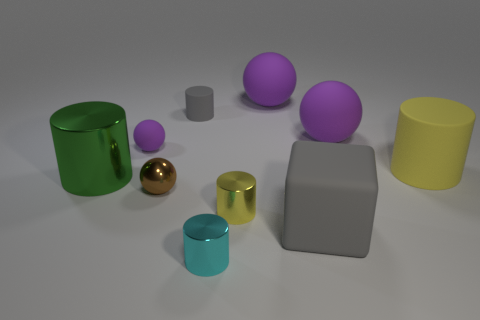How would you describe the arrangement of objects on the table? The objects are arranged seemingly at random across a flat surface. There are variously colored geometric shapes and volumes, including spheres, cylinders, and cuboids. These objects appear to be made of different materials, giving off various levels of shininess, suggesting they could be used as a study in textures and light reflections. 